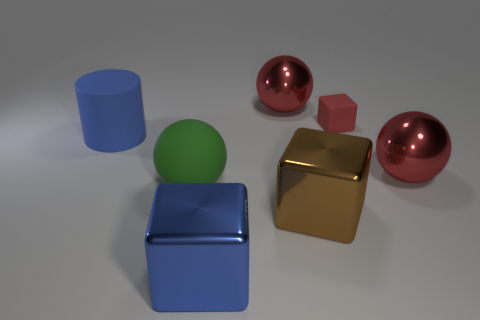Are there any other things that have the same size as the red cube?
Keep it short and to the point. No. What number of things are either small cyan metallic things or large blocks?
Provide a succinct answer. 2. The blue block that is in front of the shiny block behind the big blue object on the right side of the blue rubber cylinder is made of what material?
Make the answer very short. Metal. What is the material of the red ball that is behind the matte cube?
Offer a terse response. Metal. Are there any green objects that have the same size as the brown object?
Your answer should be very brief. Yes. Is the color of the metallic object in front of the big brown shiny object the same as the cylinder?
Your response must be concise. Yes. What number of purple things are matte cylinders or shiny balls?
Offer a very short reply. 0. What number of big shiny blocks are the same color as the small rubber block?
Offer a very short reply. 0. Do the large brown object and the large blue cylinder have the same material?
Make the answer very short. No. There is a metallic ball that is to the left of the large brown metal object; what number of cubes are in front of it?
Your response must be concise. 3. 